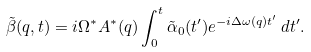Convert formula to latex. <formula><loc_0><loc_0><loc_500><loc_500>\tilde { \beta } ( q , t ) = i \Omega ^ { * } A ^ { * } ( q ) \int _ { 0 } ^ { t } \tilde { \alpha } _ { 0 } ( t ^ { \prime } ) e ^ { - i \Delta \omega ( q ) t ^ { \prime } } \, d t ^ { \prime } .</formula> 